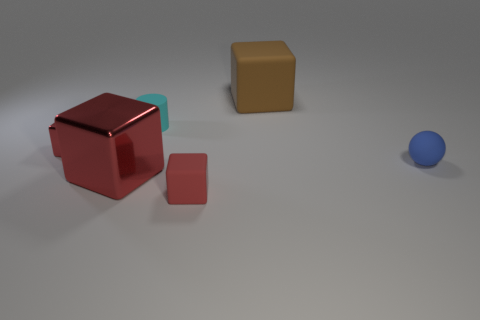Is the blue thing the same size as the cyan rubber cylinder?
Your answer should be compact. Yes. What number of cylinders are small cyan shiny objects or blue objects?
Provide a succinct answer. 0. What is the color of the small cube right of the big thing that is on the left side of the large matte cube?
Give a very brief answer. Red. Is the number of large brown matte blocks that are left of the tiny matte cylinder less than the number of blue spheres in front of the large red shiny thing?
Your answer should be very brief. No. Is the size of the blue object the same as the red metallic cube behind the blue matte ball?
Offer a very short reply. Yes. What shape is the red thing that is both to the left of the small cyan thing and in front of the small red metallic cube?
Offer a very short reply. Cube. There is a red cube that is the same material as the cylinder; what is its size?
Your response must be concise. Small. There is a tiny rubber object in front of the ball; how many objects are to the left of it?
Provide a short and direct response. 3. Does the small red cube that is to the left of the red matte thing have the same material as the blue object?
Offer a very short reply. No. Is there any other thing that has the same material as the small blue object?
Offer a very short reply. Yes. 